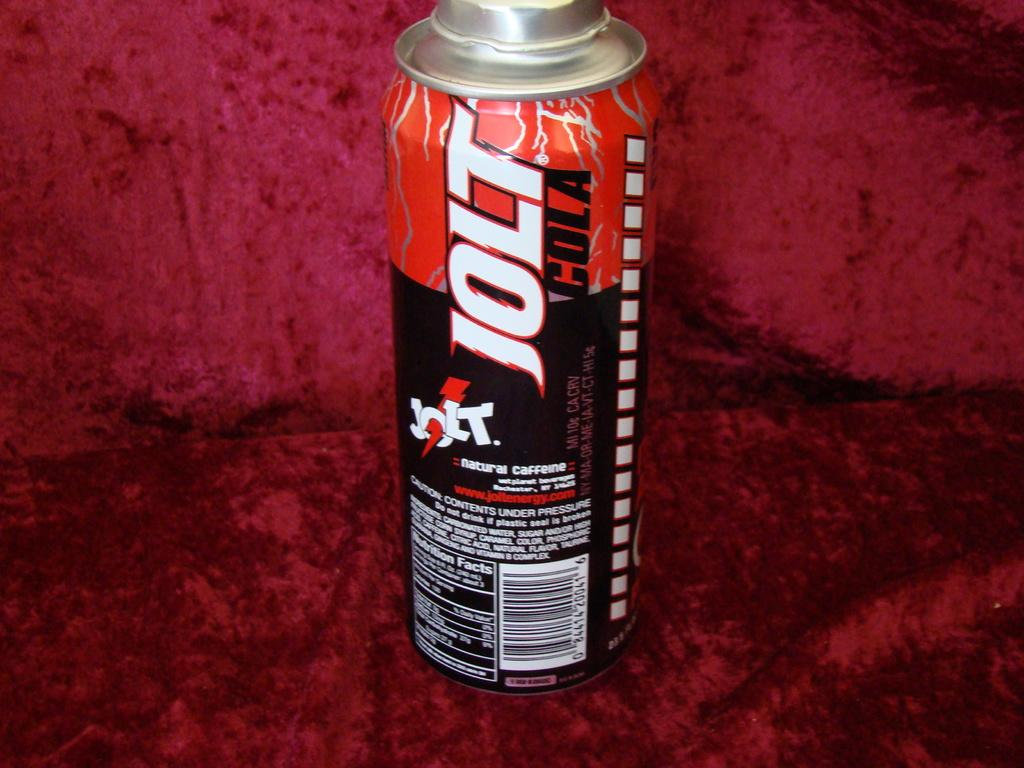<image>
Give a short and clear explanation of the subsequent image. The natural caffeine drink is called Jolt Cola. 